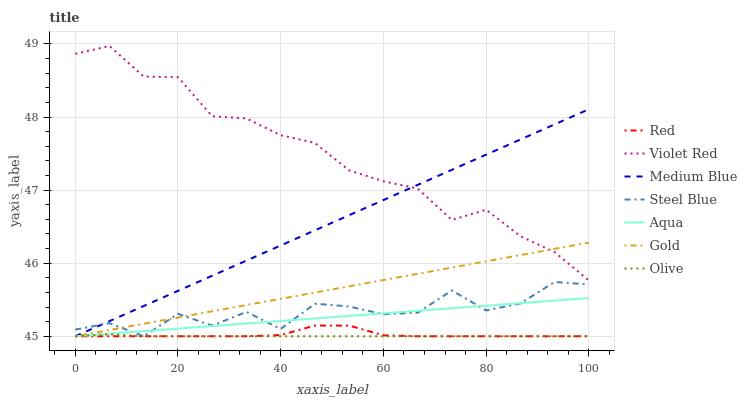Does Olive have the minimum area under the curve?
Answer yes or no. Yes. Does Violet Red have the maximum area under the curve?
Answer yes or no. Yes. Does Gold have the minimum area under the curve?
Answer yes or no. No. Does Gold have the maximum area under the curve?
Answer yes or no. No. Is Aqua the smoothest?
Answer yes or no. Yes. Is Steel Blue the roughest?
Answer yes or no. Yes. Is Gold the smoothest?
Answer yes or no. No. Is Gold the roughest?
Answer yes or no. No. Does Gold have the lowest value?
Answer yes or no. Yes. Does Violet Red have the highest value?
Answer yes or no. Yes. Does Gold have the highest value?
Answer yes or no. No. Is Red less than Violet Red?
Answer yes or no. Yes. Is Violet Red greater than Aqua?
Answer yes or no. Yes. Does Red intersect Medium Blue?
Answer yes or no. Yes. Is Red less than Medium Blue?
Answer yes or no. No. Is Red greater than Medium Blue?
Answer yes or no. No. Does Red intersect Violet Red?
Answer yes or no. No. 